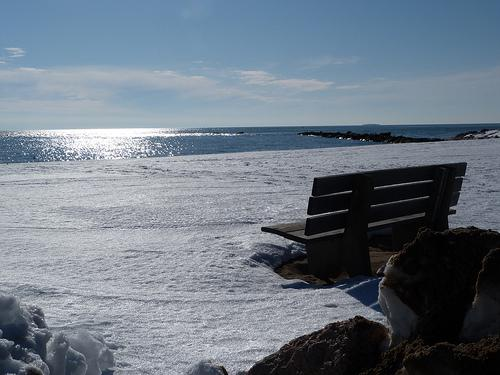Question: what is covering the sand of the beach?
Choices:
A. Rocks.
B. Leaves.
C. Snow.
D. Grass.
Answer with the letter. Answer: C Question: what color is the water?
Choices:
A. Blue.
B. Green.
C. Brown.
D. Red.
Answer with the letter. Answer: A Question: what is sticking out of the water?
Choices:
A. Plants.
B. Rocks.
C. Debris.
D. Animals.
Answer with the letter. Answer: B Question: what color are the rocks?
Choices:
A. Black.
B. White.
C. Brown.
D. Grey.
Answer with the letter. Answer: C Question: where is the picture taken?
Choices:
A. The forest.
B. The beach.
C. The city.
D. The mountain.
Answer with the letter. Answer: B 